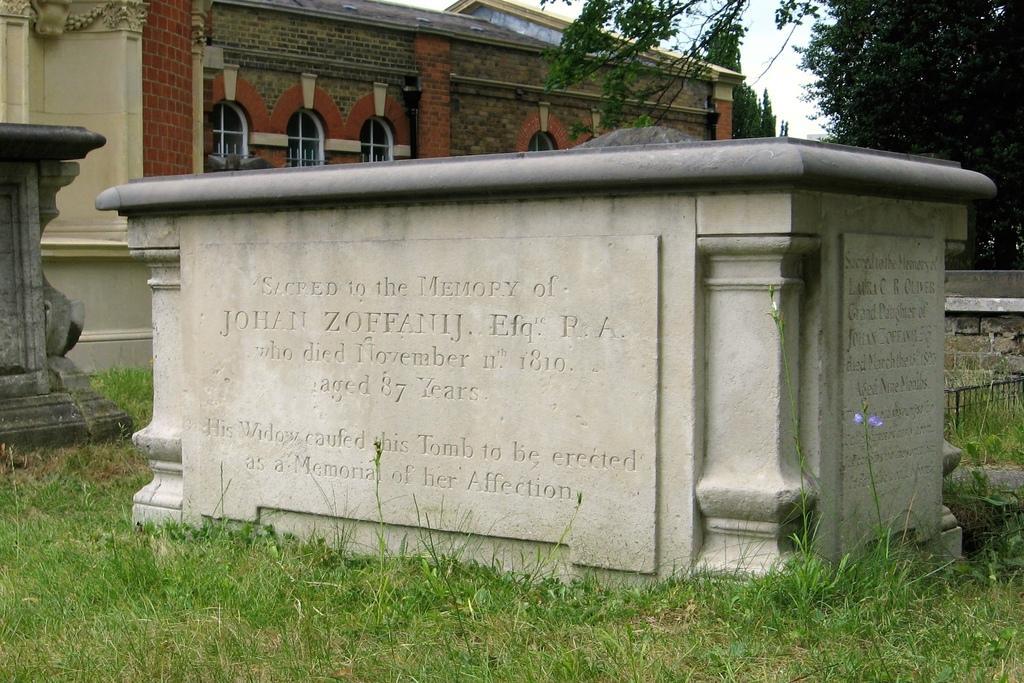How would you summarize this image in a sentence or two? In this image, It looks like a memorial stone with the letters carved on it. I can see the grass. This looks like a building with windows. On the right side of the image, I can see the trees. On the left side of the image, I think this is another memorial stone. 